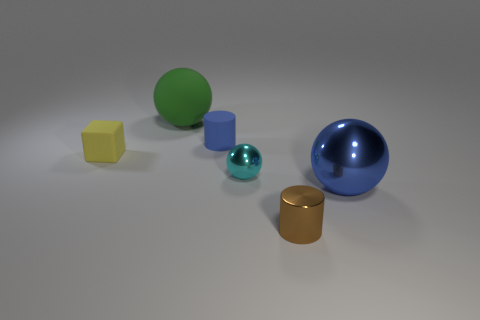There is a small matte object that is in front of the blue cylinder; is it the same shape as the brown shiny object?
Offer a terse response. No. The other ball that is the same material as the big blue sphere is what color?
Provide a succinct answer. Cyan. There is a small cylinder that is behind the big blue shiny thing; what is its material?
Offer a terse response. Rubber. Does the big blue object have the same shape as the large thing that is to the left of the small rubber cylinder?
Ensure brevity in your answer.  Yes. What material is the sphere that is both to the left of the big blue metallic object and on the right side of the green rubber thing?
Ensure brevity in your answer.  Metal. The sphere that is the same size as the blue cylinder is what color?
Ensure brevity in your answer.  Cyan. Are the yellow thing and the blue thing left of the tiny brown metallic cylinder made of the same material?
Make the answer very short. Yes. How many other things are the same size as the matte ball?
Your answer should be compact. 1. Is there a large green rubber thing to the left of the tiny yellow matte block left of the big sphere that is behind the blue ball?
Give a very brief answer. No. The blue ball has what size?
Make the answer very short. Large. 